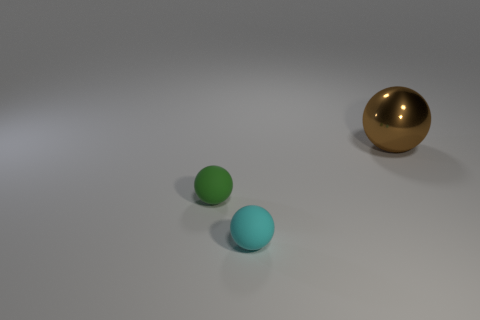Are there any other things that are the same material as the brown object?
Offer a very short reply. No. Are there any big objects on the left side of the large metallic ball?
Provide a short and direct response. No. There is a ball that is on the right side of the cyan sphere; how many cyan balls are left of it?
Keep it short and to the point. 1. What is the material of the green object that is the same size as the cyan matte thing?
Your response must be concise. Rubber. How many other things are made of the same material as the small green sphere?
Offer a terse response. 1. There is a big shiny object; what number of objects are left of it?
Keep it short and to the point. 2. What number of cylinders are cyan things or red rubber things?
Your response must be concise. 0. There is a sphere that is on the left side of the brown metal thing and on the right side of the tiny green matte sphere; what size is it?
Make the answer very short. Small. Do the big brown ball and the ball that is in front of the green thing have the same material?
Your response must be concise. No. How many objects are either spheres on the left side of the large brown thing or rubber objects?
Provide a succinct answer. 2. 